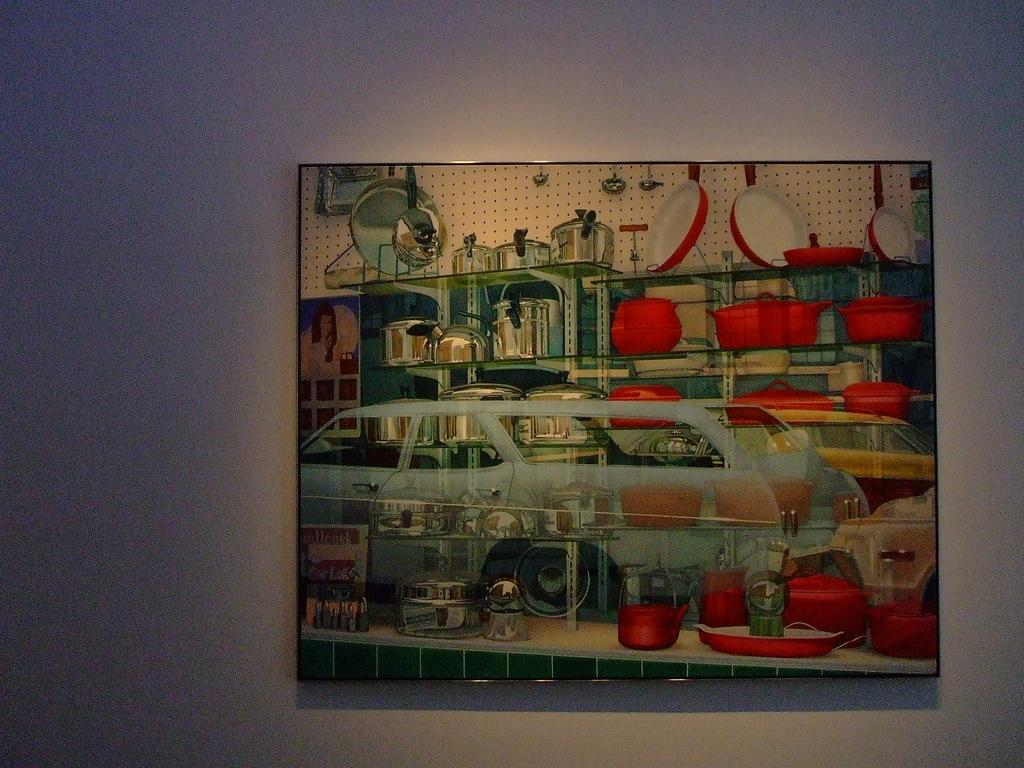What is the main object in the image? There is a board in the image. What is depicted on the board? The board has paintings on it. Where is the board located in relation to other objects or structures? The board is attached to a wall. Can you see the spy smiling and waving in the image? There is no spy, nor anyone smiling or waving, present in the image. The image only features a board with paintings on it, which is attached to a wall. 